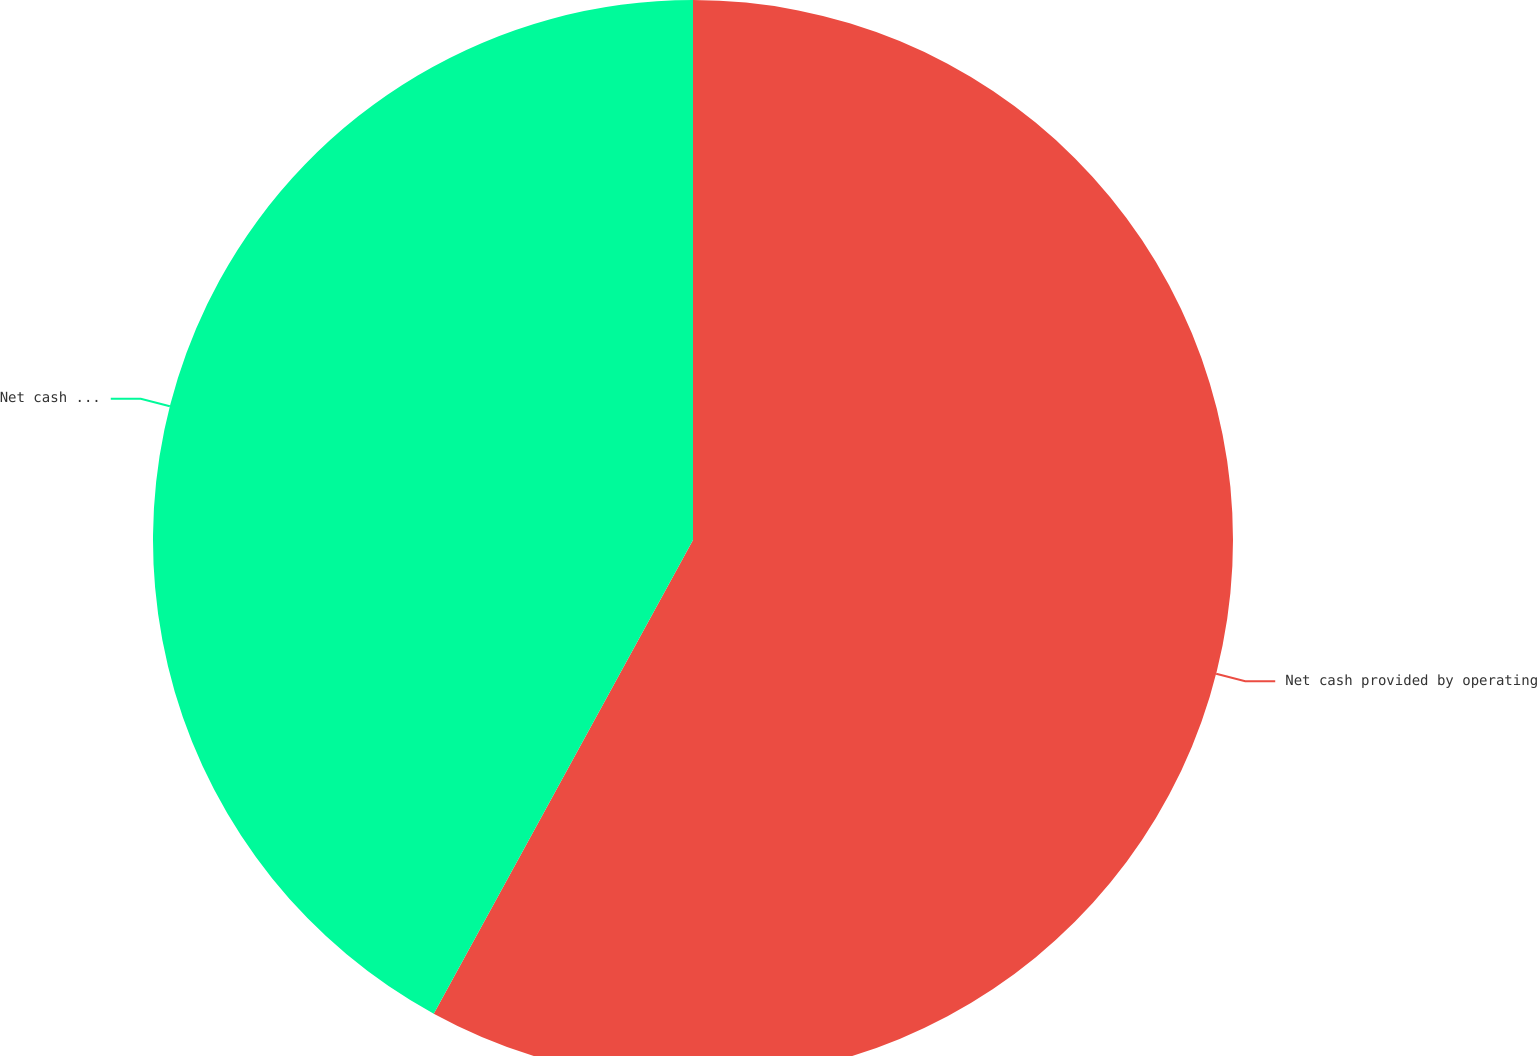Convert chart to OTSL. <chart><loc_0><loc_0><loc_500><loc_500><pie_chart><fcel>Net cash provided by operating<fcel>Net cash used in investing<nl><fcel>57.97%<fcel>42.03%<nl></chart> 